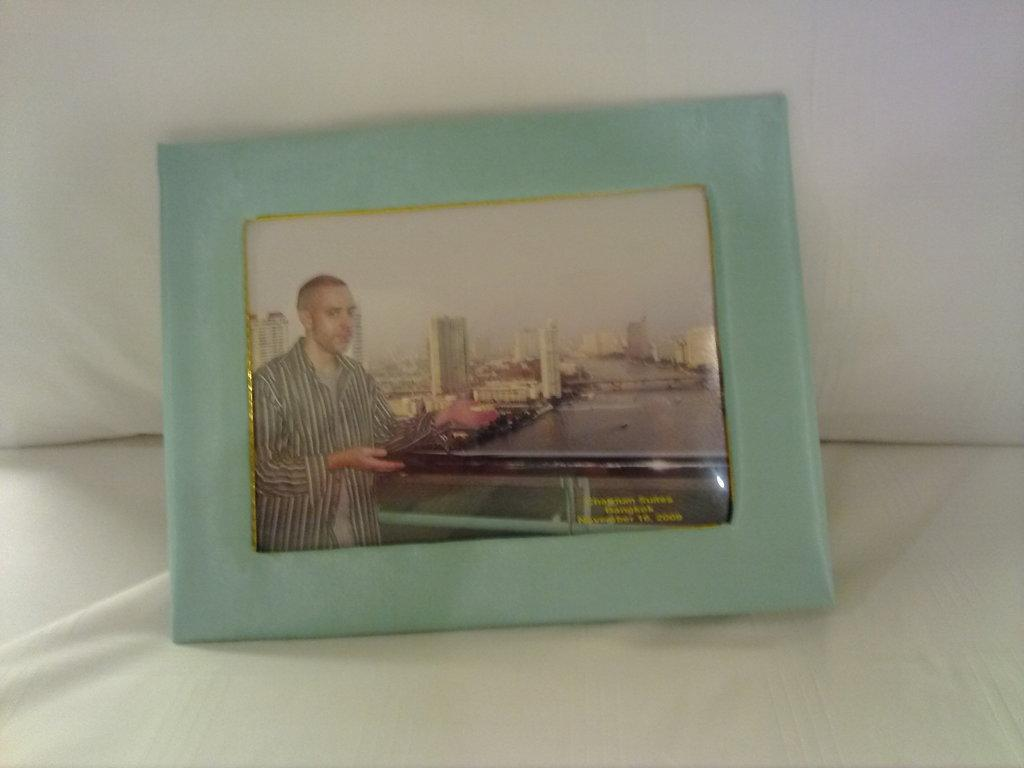What is the main object in the image? There is a frame in the image. What is depicted within the frame? The frame contains an image of a man. What can be seen in the background of the image within the frame? There are buildings visible in the frame. Are there any words or letters in the frame? Yes, there is text in the frame. Where is the frame located in the image? The frame is placed on a couch. What type of advertisement can be seen on the couch in the image? There is no advertisement present in the image; it features a frame with an image of a man, text, and buildings in the background. 